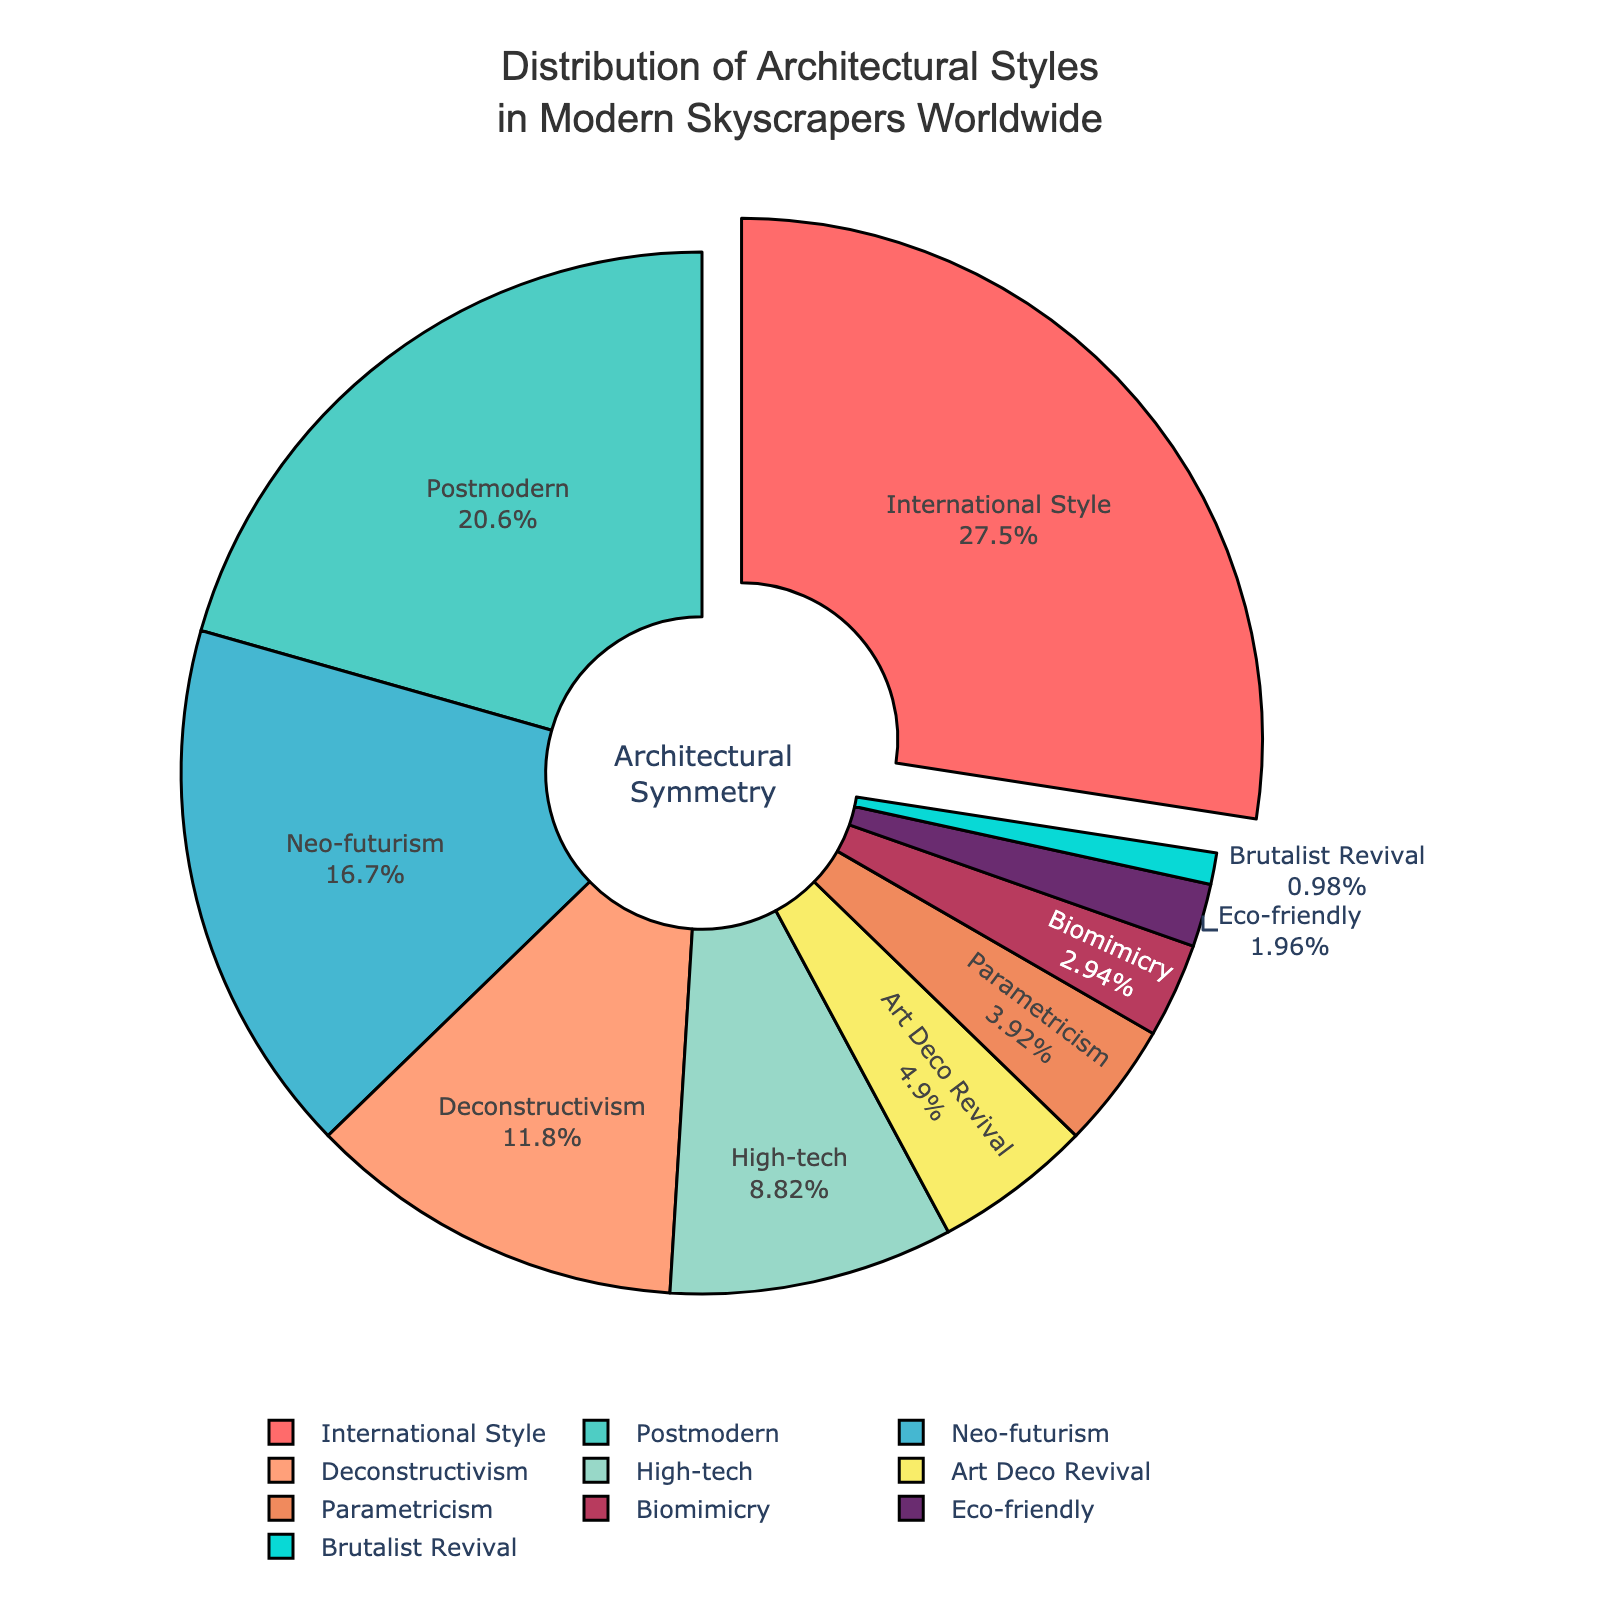What is the most common architectural style in modern skyscrapers worldwide? The largest section on the pie chart represents the International Style, which is pulled out slightly from the rest. It occupies 28% of the chart.
Answer: International Style By what percentage does Postmodern exceed Neo-futurism? The percentage for Postmodern is 21% and Neo-futurism is 17%. Subtract the percentage of Neo-futurism from Postmodern: 21% - 17% = 4%.
Answer: 4% What is the total percentage of skyscrapers that fall under Postmodern, Neo-futurism, and Deconstructivism styles combined? Add the percentages of Postmodern (21%), Neo-futurism (17%), and Deconstructivism (12%): 21% + 17% + 12% = 50%.
Answer: 50% Which architectural styles collectively account for less than 10% of the total? Add up the percentages for each style that is less than 10%: Art Deco Revival (5%), Parametricism (4%), Biomimicry (3%), Eco-friendly (2%), and Brutalist Revival (1%). These styles combine to account for less than 10%. Individually: 5%, 4%, 3%, 2%, 1%.
Answer: Art Deco Revival, Parametricism, Biomimicry, Eco-friendly, Brutalist Revival What is the combined percentage of architectural styles whose individual contributions are under 5%? Sum the percentages for styles under 5%: Art Deco Revival (5%), Parametricism (4%), Biomimicry (3%), Eco-friendly (2%), Brutalist Revival (1%). This sums to: 5% + 4% + 3% + 2% + 1% = 15%.
Answer: 15% Is the percentage of High-tech architectural style greater than the percentage of Deconstructivism? Compare the percentages: High-tech is 9% and Deconstructivism is 12%. 9% is less than 12%.
Answer: No Which architectural style is represented by the light green color? The light green section of the pie chart represents the International Style. It accounts for 28%.
Answer: International Style How many styles each make up less than or equal to 5% of the total distribution? Count the styles that are less than or equal to 5%: Art Deco Revival (5%), Parametricism (4%), Biomimicry (3%), Eco-friendly (2%), Brutalist Revival (1%). There are five such styles.
Answer: 5 What is the difference in percentage between the International Style and High-tech styles? The percentage for International Style is 28% and for High-tech it is 9%. Subtract High-tech from International Style: 28% - 9% = 19%.
Answer: 19% Which style occupies the smallest section of the pie chart and what is its percentage? The smallest section in the pie chart represents Brutalist Revival. It accounts for 1% of the distribution.
Answer: Brutalist Revival, 1% 